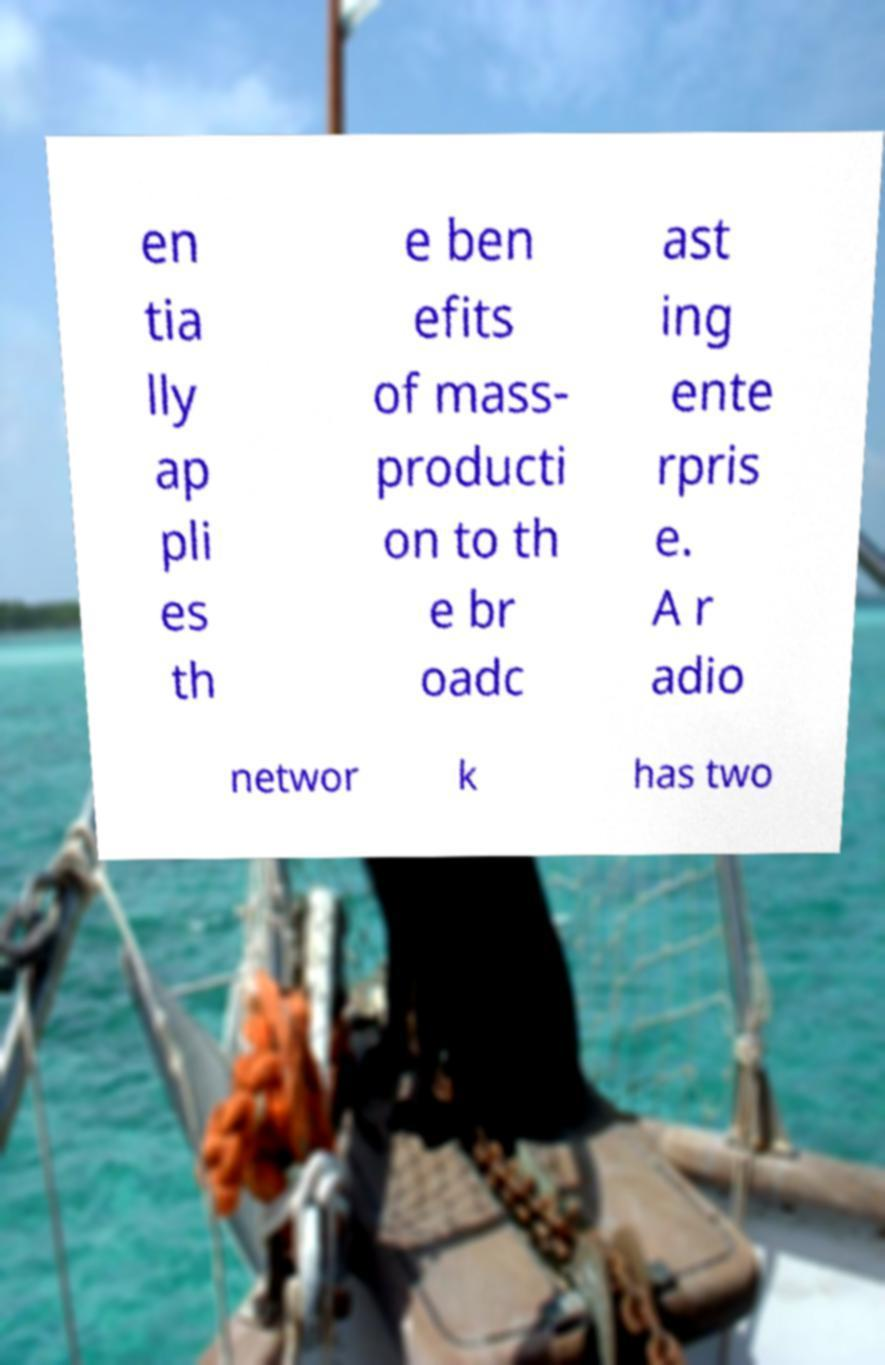For documentation purposes, I need the text within this image transcribed. Could you provide that? en tia lly ap pli es th e ben efits of mass- producti on to th e br oadc ast ing ente rpris e. A r adio networ k has two 